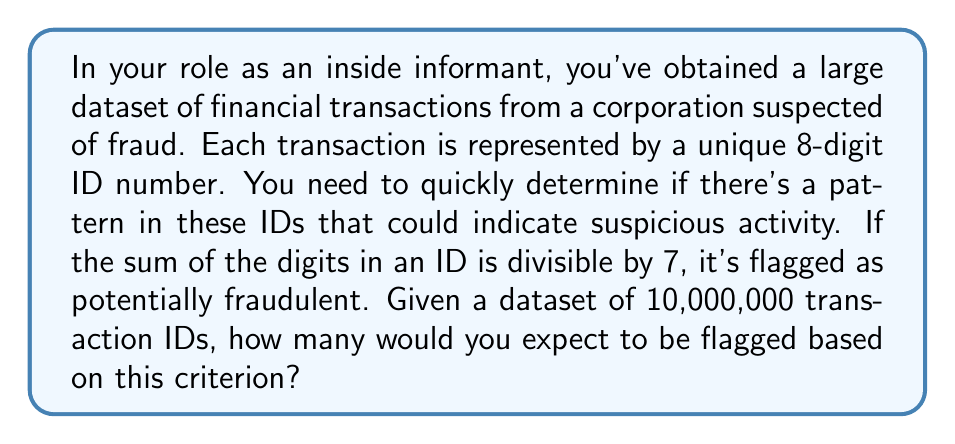Provide a solution to this math problem. Let's approach this step-by-step using modular arithmetic:

1) First, we need to understand what it means for a number to be divisible by 7. In modular arithmetic, this is equivalent to the number being congruent to 0 modulo 7.

2) For an 8-digit number, each digit can be any value from 0 to 9. The sum of these digits can range from 0 (00000000) to 72 (99999999).

3) The key insight is that the distribution of these sums modulo 7 is uniform for large datasets. This is because the sum of digits doesn't depend on the position of the digits, and all digits are equally likely in a random distribution.

4) There are 7 possible remainders when dividing by 7 (0, 1, 2, 3, 4, 5, 6), and each is equally likely to occur.

5) Therefore, the probability of any given number having a sum of digits divisible by 7 is $\frac{1}{7}$.

6) With 10,000,000 transaction IDs, we can expect approximately:

   $$10,000,000 \times \frac{1}{7} = 1,428,571.43$$

7) Since we're dealing with whole numbers of transactions, we round this to the nearest integer.

Thus, we would expect approximately 1,428,571 transaction IDs to be flagged as potentially fraudulent.
Answer: 1,428,571 